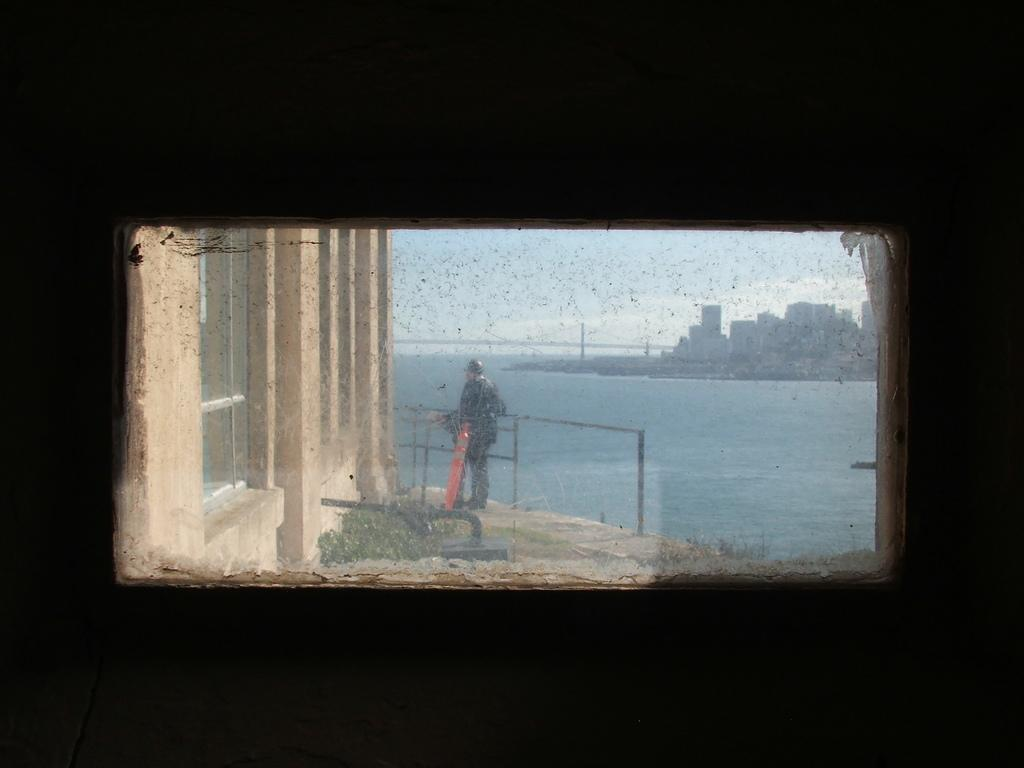What is located on the wall in the image? There is a window on the wall in the image. What can be seen through the window? Buildings, water, plants, and a person can be seen through the window. What is visible in the background of the image? The sky is visible in the background of the image. What can be observed in the sky? Clouds are present in the sky. What is the value of the glass in the image? There is no glass present in the image; it features a window with various elements visible through it. What type of head is visible through the window? There is no head visible through the window; a person is visible, but their head is not the focus of the image. 